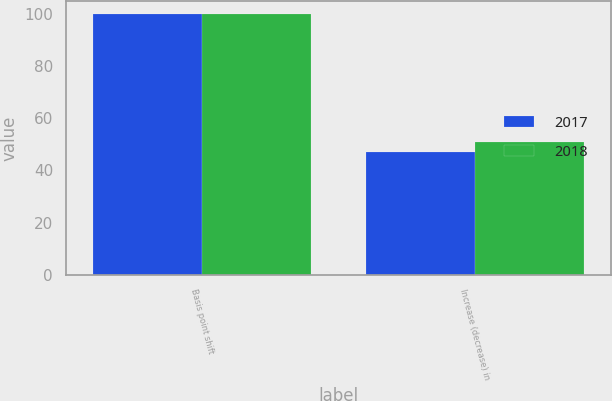Convert chart to OTSL. <chart><loc_0><loc_0><loc_500><loc_500><stacked_bar_chart><ecel><fcel>Basis point shift<fcel>Increase (decrease) in<nl><fcel>2017<fcel>100<fcel>47<nl><fcel>2018<fcel>100<fcel>51<nl></chart> 